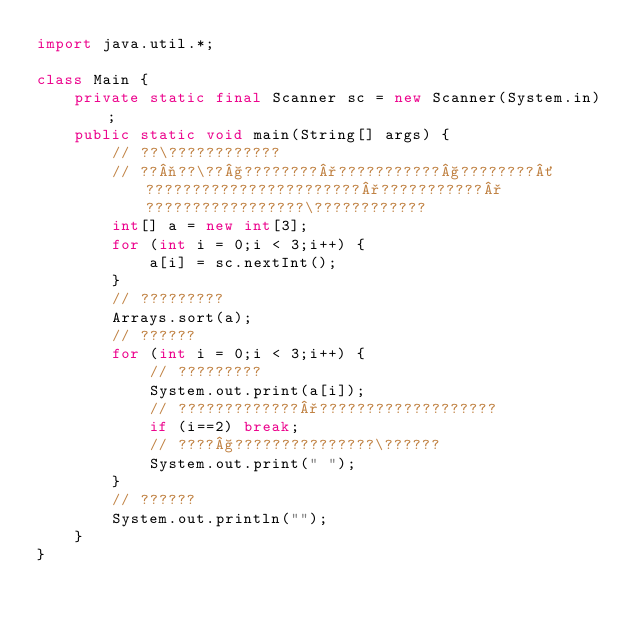<code> <loc_0><loc_0><loc_500><loc_500><_Java_>import java.util.*;

class Main {
    private static final Scanner sc = new Scanner(System.in);
    public static void main(String[] args) {
        // ??\????????????
        // ??¬??\??§????????°???????????§????????´???????????????????????°???????????°?????????????????\????????????
        int[] a = new int[3];
        for (int i = 0;i < 3;i++) {
            a[i] = sc.nextInt();
        }
        // ?????????
        Arrays.sort(a);
        // ??????
        for (int i = 0;i < 3;i++) {
            // ?????????
            System.out.print(a[i]);
            // ?????????????°???????????????????
            if (i==2) break;
            // ????§???????????????\??????
            System.out.print(" ");
        }
        // ??????
        System.out.println("");
    }
}</code> 